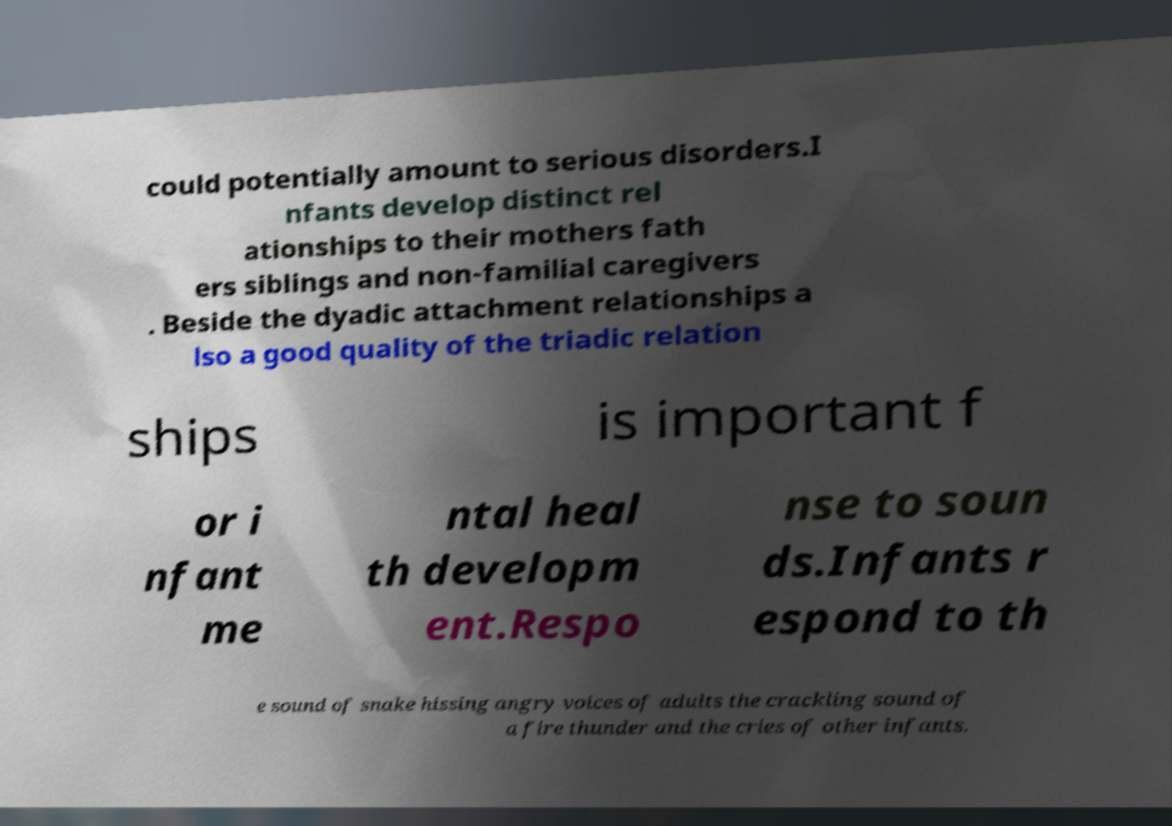There's text embedded in this image that I need extracted. Can you transcribe it verbatim? could potentially amount to serious disorders.I nfants develop distinct rel ationships to their mothers fath ers siblings and non-familial caregivers . Beside the dyadic attachment relationships a lso a good quality of the triadic relation ships is important f or i nfant me ntal heal th developm ent.Respo nse to soun ds.Infants r espond to th e sound of snake hissing angry voices of adults the crackling sound of a fire thunder and the cries of other infants. 